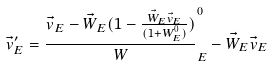Convert formula to latex. <formula><loc_0><loc_0><loc_500><loc_500>\vec { v } _ { E } ^ { \prime } = \frac { \vec { v } _ { E } - \vec { W } _ { E } ( 1 - \frac { \vec { W } _ { E } \vec { v } _ { E } } { ( 1 + W _ { E } ^ { 0 } ) } ) } W _ { E } ^ { 0 } - \vec { W } _ { E } \vec { v } _ { E }</formula> 